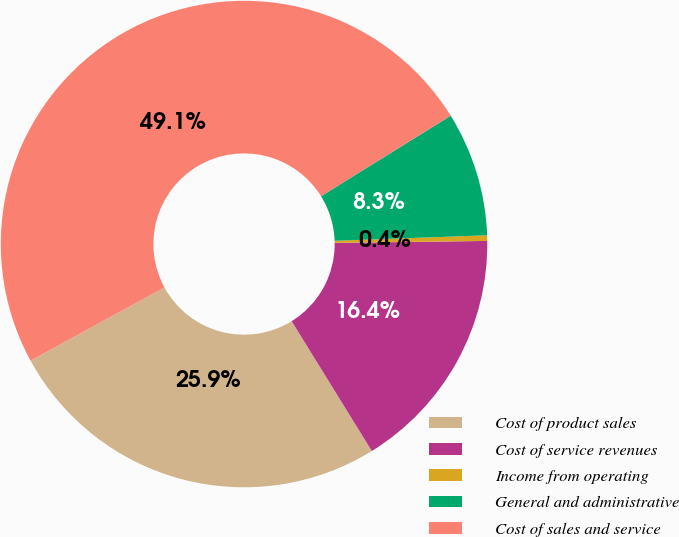<chart> <loc_0><loc_0><loc_500><loc_500><pie_chart><fcel>Cost of product sales<fcel>Cost of service revenues<fcel>Income from operating<fcel>General and administrative<fcel>Cost of sales and service<nl><fcel>25.85%<fcel>16.4%<fcel>0.37%<fcel>8.27%<fcel>49.11%<nl></chart> 